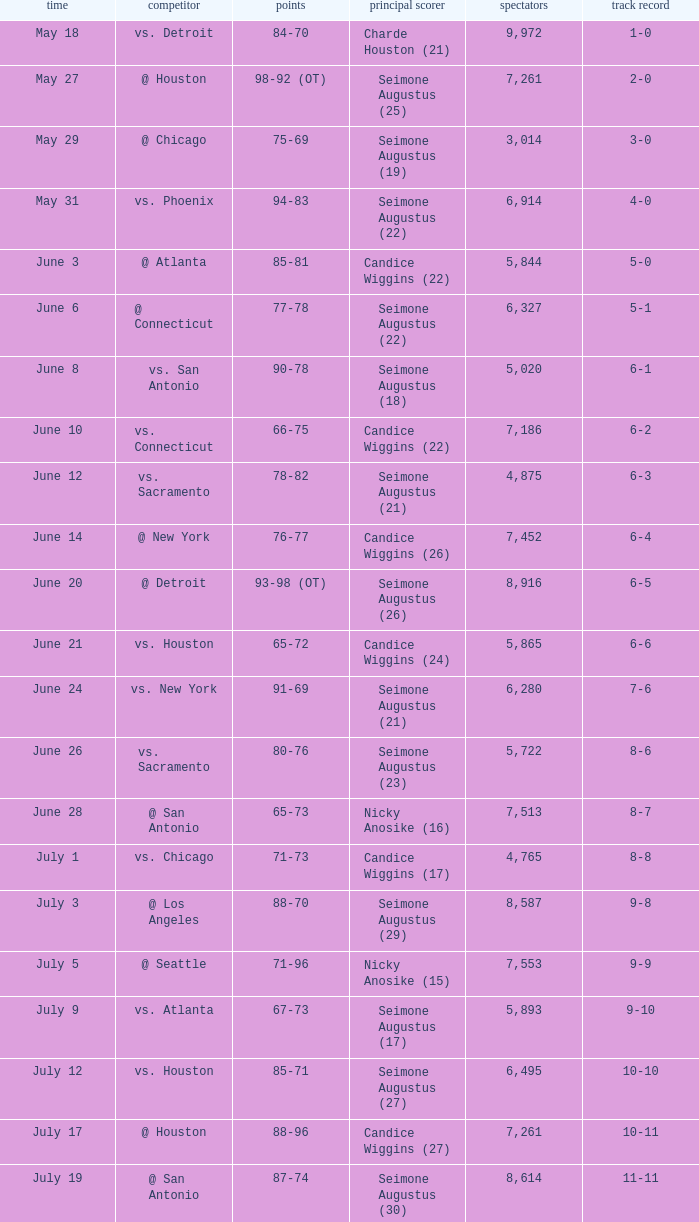Write the full table. {'header': ['time', 'competitor', 'points', 'principal scorer', 'spectators', 'track record'], 'rows': [['May 18', 'vs. Detroit', '84-70', 'Charde Houston (21)', '9,972', '1-0'], ['May 27', '@ Houston', '98-92 (OT)', 'Seimone Augustus (25)', '7,261', '2-0'], ['May 29', '@ Chicago', '75-69', 'Seimone Augustus (19)', '3,014', '3-0'], ['May 31', 'vs. Phoenix', '94-83', 'Seimone Augustus (22)', '6,914', '4-0'], ['June 3', '@ Atlanta', '85-81', 'Candice Wiggins (22)', '5,844', '5-0'], ['June 6', '@ Connecticut', '77-78', 'Seimone Augustus (22)', '6,327', '5-1'], ['June 8', 'vs. San Antonio', '90-78', 'Seimone Augustus (18)', '5,020', '6-1'], ['June 10', 'vs. Connecticut', '66-75', 'Candice Wiggins (22)', '7,186', '6-2'], ['June 12', 'vs. Sacramento', '78-82', 'Seimone Augustus (21)', '4,875', '6-3'], ['June 14', '@ New York', '76-77', 'Candice Wiggins (26)', '7,452', '6-4'], ['June 20', '@ Detroit', '93-98 (OT)', 'Seimone Augustus (26)', '8,916', '6-5'], ['June 21', 'vs. Houston', '65-72', 'Candice Wiggins (24)', '5,865', '6-6'], ['June 24', 'vs. New York', '91-69', 'Seimone Augustus (21)', '6,280', '7-6'], ['June 26', 'vs. Sacramento', '80-76', 'Seimone Augustus (23)', '5,722', '8-6'], ['June 28', '@ San Antonio', '65-73', 'Nicky Anosike (16)', '7,513', '8-7'], ['July 1', 'vs. Chicago', '71-73', 'Candice Wiggins (17)', '4,765', '8-8'], ['July 3', '@ Los Angeles', '88-70', 'Seimone Augustus (29)', '8,587', '9-8'], ['July 5', '@ Seattle', '71-96', 'Nicky Anosike (15)', '7,553', '9-9'], ['July 9', 'vs. Atlanta', '67-73', 'Seimone Augustus (17)', '5,893', '9-10'], ['July 12', 'vs. Houston', '85-71', 'Seimone Augustus (27)', '6,495', '10-10'], ['July 17', '@ Houston', '88-96', 'Candice Wiggins (27)', '7,261', '10-11'], ['July 19', '@ San Antonio', '87-74', 'Seimone Augustus (30)', '8,614', '11-11'], ['July 22', 'vs. Seattle', '73-76', 'Charde Houston (16)', '12,276', '11-12'], ['July 24', '@ Indiana', '84-80 (OT)', 'Seimone Augustus (25)', '6,010', '12-12'], ['July 25', 'vs. San Antonio', '78-68', 'Seimone Augustus (20)', '7,247', '13-12'], ['July 27', 'vs. Los Angeles', '84-92 (OT)', 'Seimone Augustus (29)', '9,433', '13-13'], ['August 30', 'vs. Washington', '92-78', 'Candice Wiggins (22)', '6,980', '14-13'], ['September 1', '@ Los Angeles', '58-82', 'Seimone Augustus (13)', '9,072', '14-14'], ['September 3', '@ Phoenix', '96-103', 'Seimone Augustus (27)', '7,722', '14-15'], ['September 6', '@ Seattle', '88-96', 'Seimone Augustus (26)', '9,339', '14-16'], ['September 7', '@ Sacramento', '71-78', 'Charde Houston (19)', '7,999', '14-17'], ['September 9', 'vs. Indiana', '86-76', 'Charde Houston (18)', '6,706', '15-17'], ['September 12', 'vs. Phoenix', '87-96', 'Lindsey Harding (20)', '8,343', '15-18'], ['September 14', '@ Washington', '96-70', 'Charde Houston (18)', '10,438', '16-18']]} Which Score has an Opponent of @ houston, and a Record of 2-0? 98-92 (OT). 